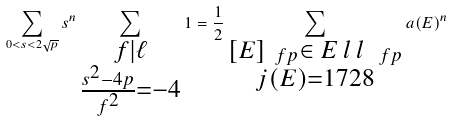Convert formula to latex. <formula><loc_0><loc_0><loc_500><loc_500>\sum _ { 0 < s < 2 \sqrt { p } } s ^ { n } \sum _ { \substack { f | \ell \\ \frac { s ^ { 2 } - 4 p } { f ^ { 2 } } = - 4 } } 1 = \frac { 1 } { 2 } \sum _ { \substack { [ E ] _ { \ f p } \in \emph { E l l } _ { \ f p } \\ j ( E ) = 1 7 2 8 } } a ( E ) ^ { n }</formula> 